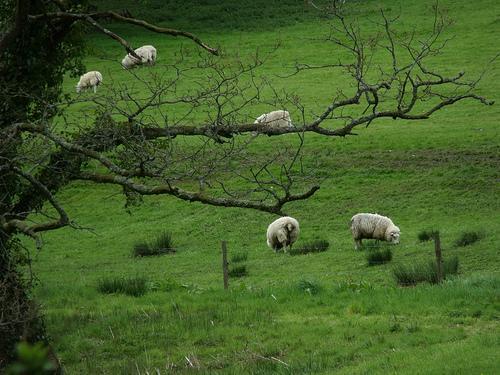How many sheep are in the photo?
Give a very brief answer. 5. How many sheep are shown?
Give a very brief answer. 5. 